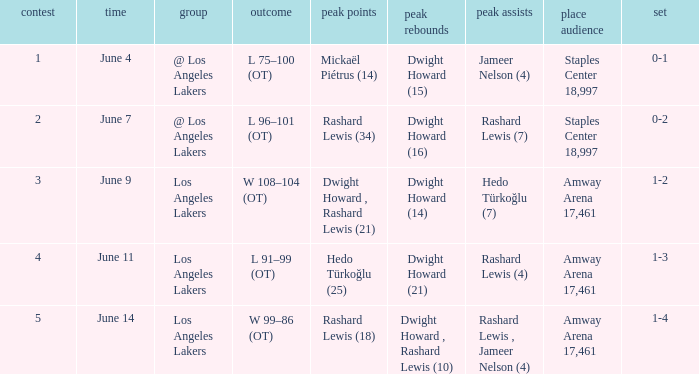What is High Points, when High Rebounds is "Dwight Howard (16)"? Rashard Lewis (34). 